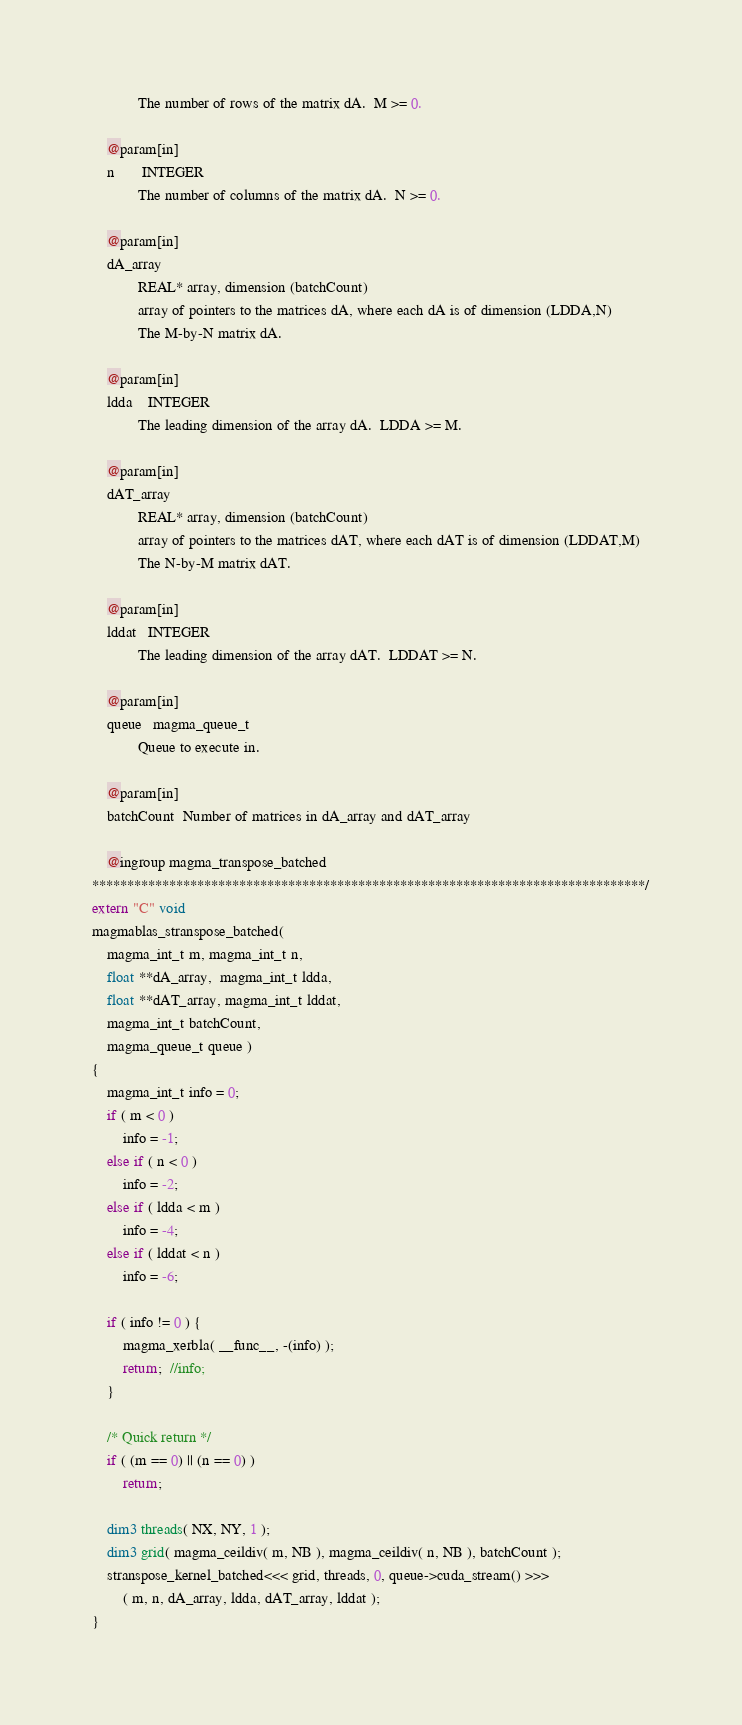<code> <loc_0><loc_0><loc_500><loc_500><_Cuda_>            The number of rows of the matrix dA.  M >= 0.
    
    @param[in]
    n       INTEGER
            The number of columns of the matrix dA.  N >= 0.
    
    @param[in]
    dA_array 
            REAL* array, dimension (batchCount)
            array of pointers to the matrices dA, where each dA is of dimension (LDDA,N)
            The M-by-N matrix dA.
    
    @param[in]
    ldda    INTEGER
            The leading dimension of the array dA.  LDDA >= M.
    
    @param[in]
    dAT_array     
            REAL* array, dimension (batchCount)
            array of pointers to the matrices dAT, where each dAT is of dimension (LDDAT,M)
            The N-by-M matrix dAT.
    
    @param[in]
    lddat   INTEGER
            The leading dimension of the array dAT.  LDDAT >= N.
    
    @param[in]
    queue   magma_queue_t
            Queue to execute in.
    
    @param[in]
    batchCount  Number of matrices in dA_array and dAT_array

    @ingroup magma_transpose_batched
*******************************************************************************/
extern "C" void
magmablas_stranspose_batched(
    magma_int_t m, magma_int_t n,
    float **dA_array,  magma_int_t ldda,
    float **dAT_array, magma_int_t lddat,
    magma_int_t batchCount,
    magma_queue_t queue )
{
    magma_int_t info = 0;
    if ( m < 0 )
        info = -1;
    else if ( n < 0 )
        info = -2;
    else if ( ldda < m )
        info = -4;
    else if ( lddat < n )
        info = -6;
    
    if ( info != 0 ) {
        magma_xerbla( __func__, -(info) );
        return;  //info;
    }
    
    /* Quick return */
    if ( (m == 0) || (n == 0) )
        return;

    dim3 threads( NX, NY, 1 );
    dim3 grid( magma_ceildiv( m, NB ), magma_ceildiv( n, NB ), batchCount );
    stranspose_kernel_batched<<< grid, threads, 0, queue->cuda_stream() >>>
        ( m, n, dA_array, ldda, dAT_array, lddat );
}
</code> 